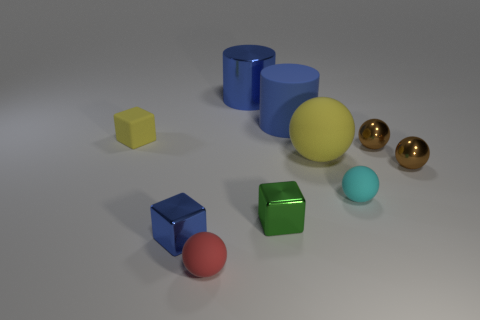What shape is the small object that is the same color as the big matte cylinder?
Give a very brief answer. Cube. There is a object that is right of the tiny green block and behind the small yellow cube; how big is it?
Provide a short and direct response. Large. There is a tiny yellow thing that is left of the tiny shiny ball that is in front of the yellow thing that is to the right of the green block; what is its material?
Provide a short and direct response. Rubber. There is another big cylinder that is the same color as the metallic cylinder; what material is it?
Give a very brief answer. Rubber. There is a cube that is behind the yellow rubber sphere; is it the same color as the large rubber object that is right of the matte cylinder?
Ensure brevity in your answer.  Yes. There is a thing in front of the tiny shiny object on the left side of the tiny matte sphere on the left side of the green cube; what is its shape?
Your response must be concise. Sphere. The tiny shiny thing that is both in front of the yellow matte sphere and to the right of the tiny cyan matte object has what shape?
Your answer should be compact. Sphere. There is a blue metallic object to the left of the tiny matte sphere that is to the left of the cyan rubber object; how many yellow objects are left of it?
Provide a succinct answer. 1. The yellow object that is the same shape as the red rubber thing is what size?
Provide a succinct answer. Large. Is there anything else that is the same size as the red rubber sphere?
Your answer should be compact. Yes. 